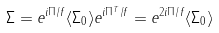Convert formula to latex. <formula><loc_0><loc_0><loc_500><loc_500>\Sigma = e ^ { i \Pi / f } \langle \Sigma _ { 0 } \rangle e ^ { i \Pi ^ { T } / f } = e ^ { 2 i \Pi / f } \langle \Sigma _ { 0 } \rangle</formula> 